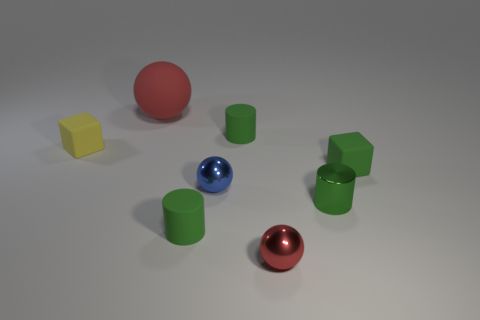Which objects seem to reflect the most light? The objects that reflect the most light are the large red rubber sphere and the blue sphere. Their specular highlights indicate they have shiny surfaces. Meanwhile, the yellow and green cubes, as well as the green cylinders, reflect less light, indicating that their surfaces are matte. How can you tell the difference between shiny and matte objects? Shiny objects have bright spots known as specular highlights, where light sources are being directly reflected. They also have high contrast reflections, whereas matte objects scatter light more diffusely, resulting in a more uniform surface appearance with soft or almost no noticeable reflections. 